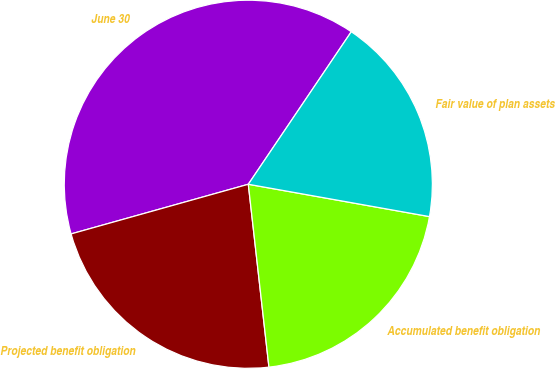Convert chart. <chart><loc_0><loc_0><loc_500><loc_500><pie_chart><fcel>June 30<fcel>Projected benefit obligation<fcel>Accumulated benefit obligation<fcel>Fair value of plan assets<nl><fcel>38.8%<fcel>22.44%<fcel>20.4%<fcel>18.36%<nl></chart> 